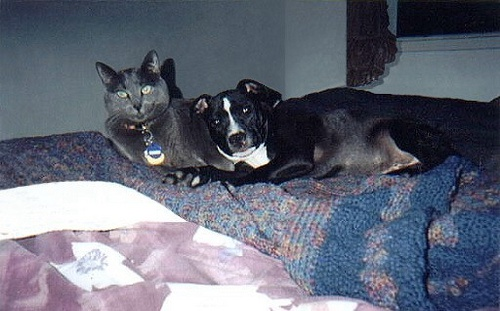Describe the objects in this image and their specific colors. I can see bed in gray, white, and darkgray tones, dog in gray, black, and lightgray tones, and cat in gray, black, and darkgray tones in this image. 